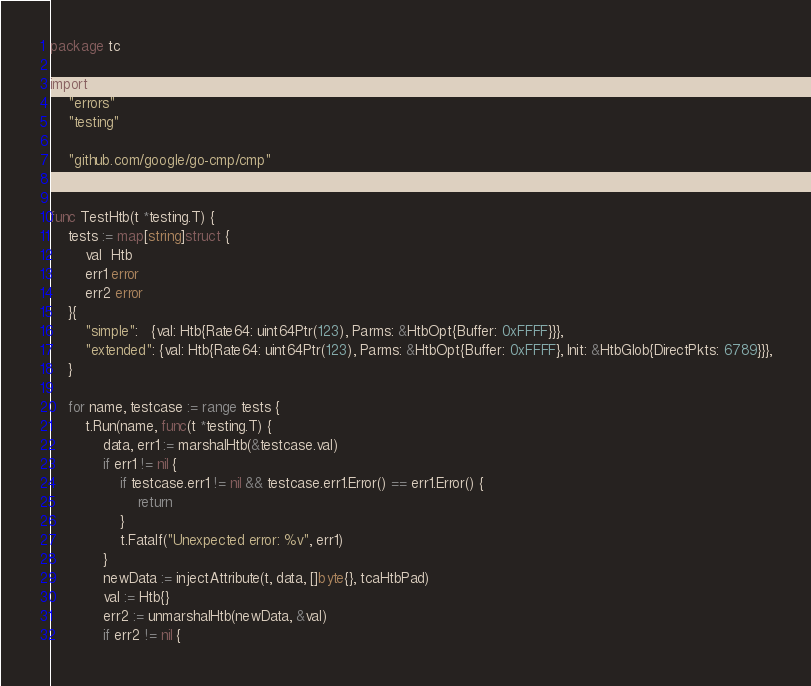Convert code to text. <code><loc_0><loc_0><loc_500><loc_500><_Go_>package tc

import (
	"errors"
	"testing"

	"github.com/google/go-cmp/cmp"
)

func TestHtb(t *testing.T) {
	tests := map[string]struct {
		val  Htb
		err1 error
		err2 error
	}{
		"simple":   {val: Htb{Rate64: uint64Ptr(123), Parms: &HtbOpt{Buffer: 0xFFFF}}},
		"extended": {val: Htb{Rate64: uint64Ptr(123), Parms: &HtbOpt{Buffer: 0xFFFF}, Init: &HtbGlob{DirectPkts: 6789}}},
	}

	for name, testcase := range tests {
		t.Run(name, func(t *testing.T) {
			data, err1 := marshalHtb(&testcase.val)
			if err1 != nil {
				if testcase.err1 != nil && testcase.err1.Error() == err1.Error() {
					return
				}
				t.Fatalf("Unexpected error: %v", err1)
			}
			newData := injectAttribute(t, data, []byte{}, tcaHtbPad)
			val := Htb{}
			err2 := unmarshalHtb(newData, &val)
			if err2 != nil {</code> 